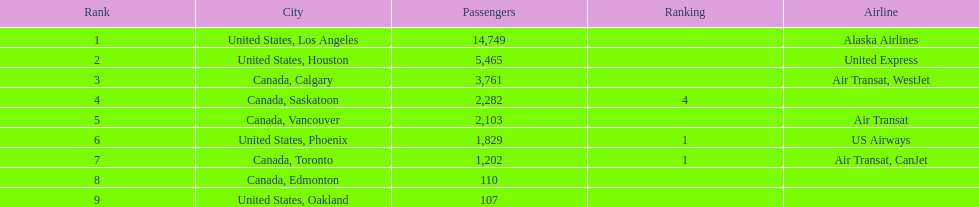Parse the full table. {'header': ['Rank', 'City', 'Passengers', 'Ranking', 'Airline'], 'rows': [['1', 'United States, Los Angeles', '14,749', '', 'Alaska Airlines'], ['2', 'United States, Houston', '5,465', '', 'United Express'], ['3', 'Canada, Calgary', '3,761', '', 'Air Transat, WestJet'], ['4', 'Canada, Saskatoon', '2,282', '4', ''], ['5', 'Canada, Vancouver', '2,103', '', 'Air Transat'], ['6', 'United States, Phoenix', '1,829', '1', 'US Airways'], ['7', 'Canada, Toronto', '1,202', '1', 'Air Transat, CanJet'], ['8', 'Canada, Edmonton', '110', '', ''], ['9', 'United States, Oakland', '107', '', '']]} What is the count of passengers in phoenix, arizona? 1,829. 